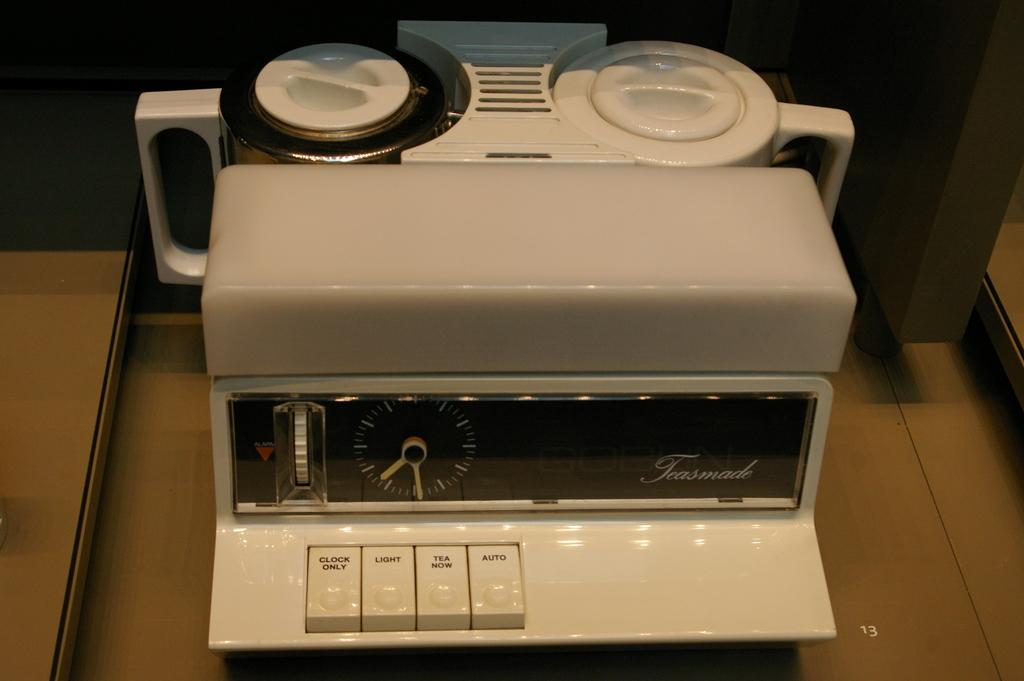<image>
Describe the image concisely. an item that has the word auto on it 